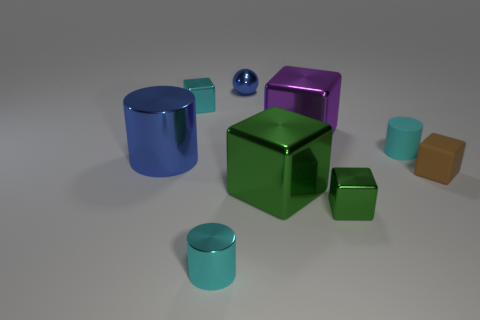Subtract all small cyan cylinders. How many cylinders are left? 1 Add 1 cyan shiny cubes. How many objects exist? 10 Subtract all green cylinders. How many green blocks are left? 2 Subtract all purple cubes. How many cubes are left? 4 Subtract all spheres. How many objects are left? 8 Add 9 big cyan metallic cylinders. How many big cyan metallic cylinders exist? 9 Subtract 0 yellow blocks. How many objects are left? 9 Subtract 1 blocks. How many blocks are left? 4 Subtract all brown cylinders. Subtract all yellow spheres. How many cylinders are left? 3 Subtract all cyan cylinders. Subtract all small cyan metal things. How many objects are left? 5 